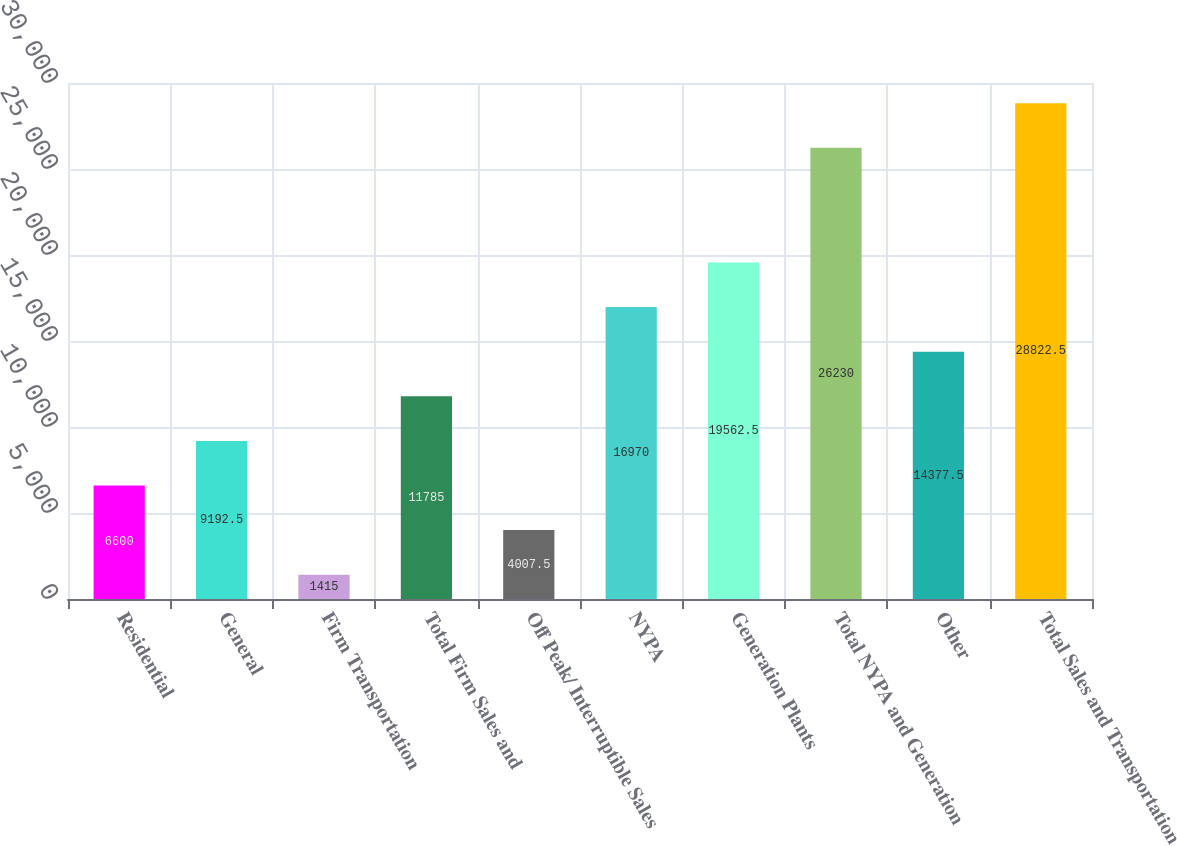<chart> <loc_0><loc_0><loc_500><loc_500><bar_chart><fcel>Residential<fcel>General<fcel>Firm Transportation<fcel>Total Firm Sales and<fcel>Off Peak/ Interruptible Sales<fcel>NYPA<fcel>Generation Plants<fcel>Total NYPA and Generation<fcel>Other<fcel>Total Sales and Transportation<nl><fcel>6600<fcel>9192.5<fcel>1415<fcel>11785<fcel>4007.5<fcel>16970<fcel>19562.5<fcel>26230<fcel>14377.5<fcel>28822.5<nl></chart> 